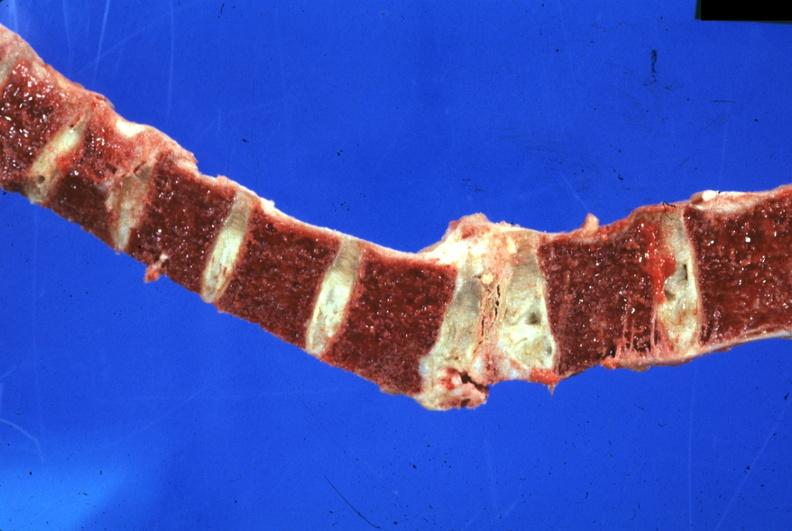what is present?
Answer the question using a single word or phrase. Joints 